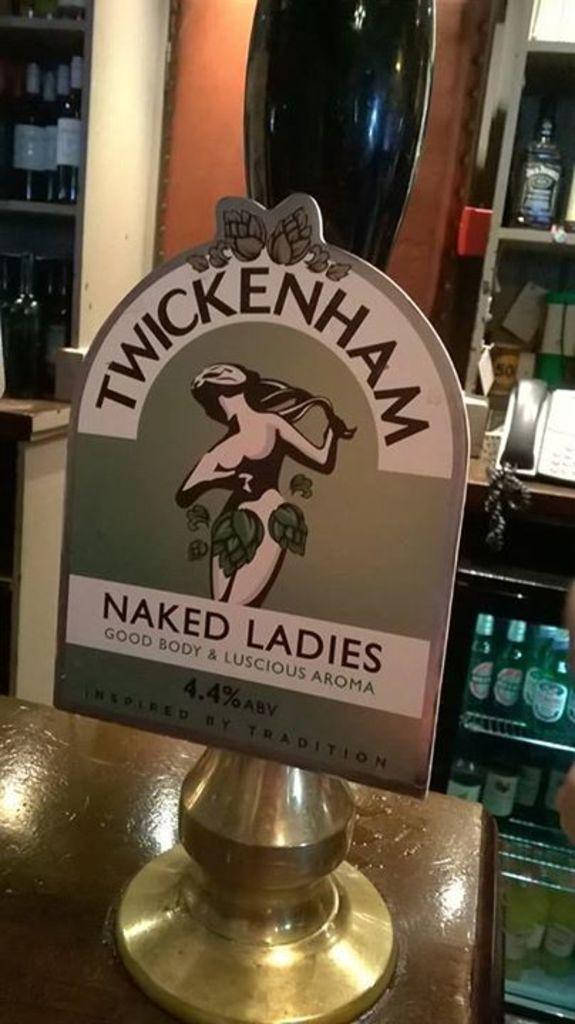<image>
Summarize the visual content of the image. a beer pump with the label 'Twickenham naked ladies' 